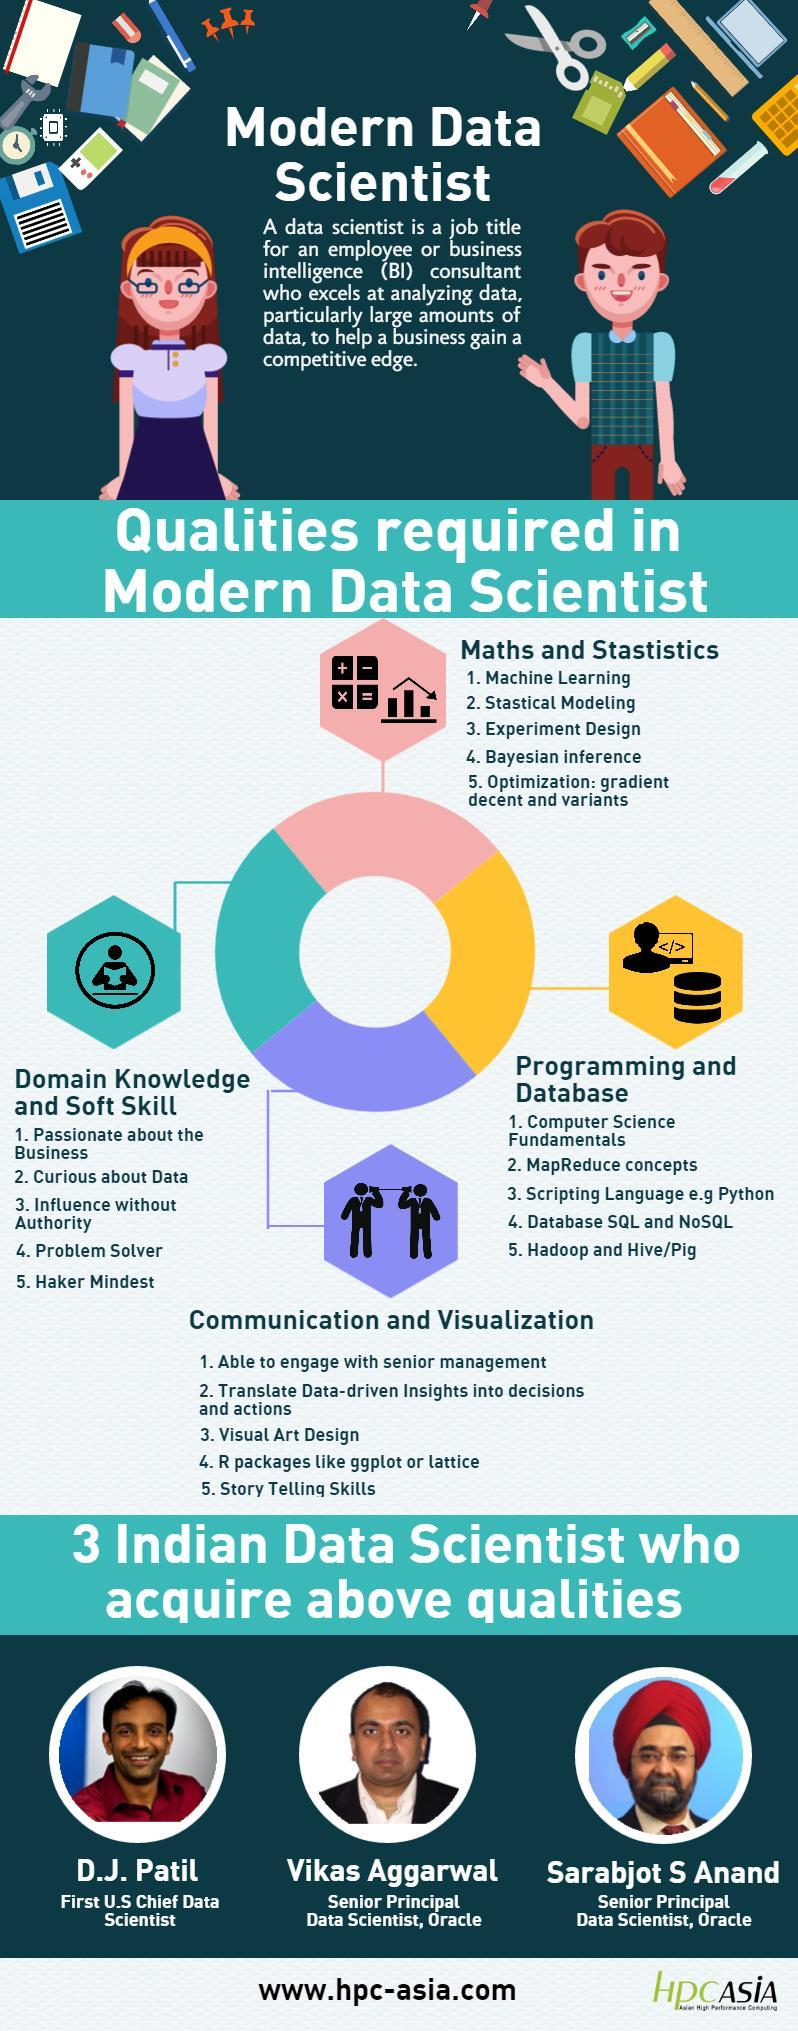Under which skill set is problem solver mentioned?
Answer the question with a short phrase. domain knowledge and soft skill Under which skill set is story telling skills mentioned? communication and visualization Python is mentioned under which skill set? Programming and database How many types of qualities required by a data scientist are shown in the infographic? 4 Hadoop is mentioned under which skill set? Programming and database 